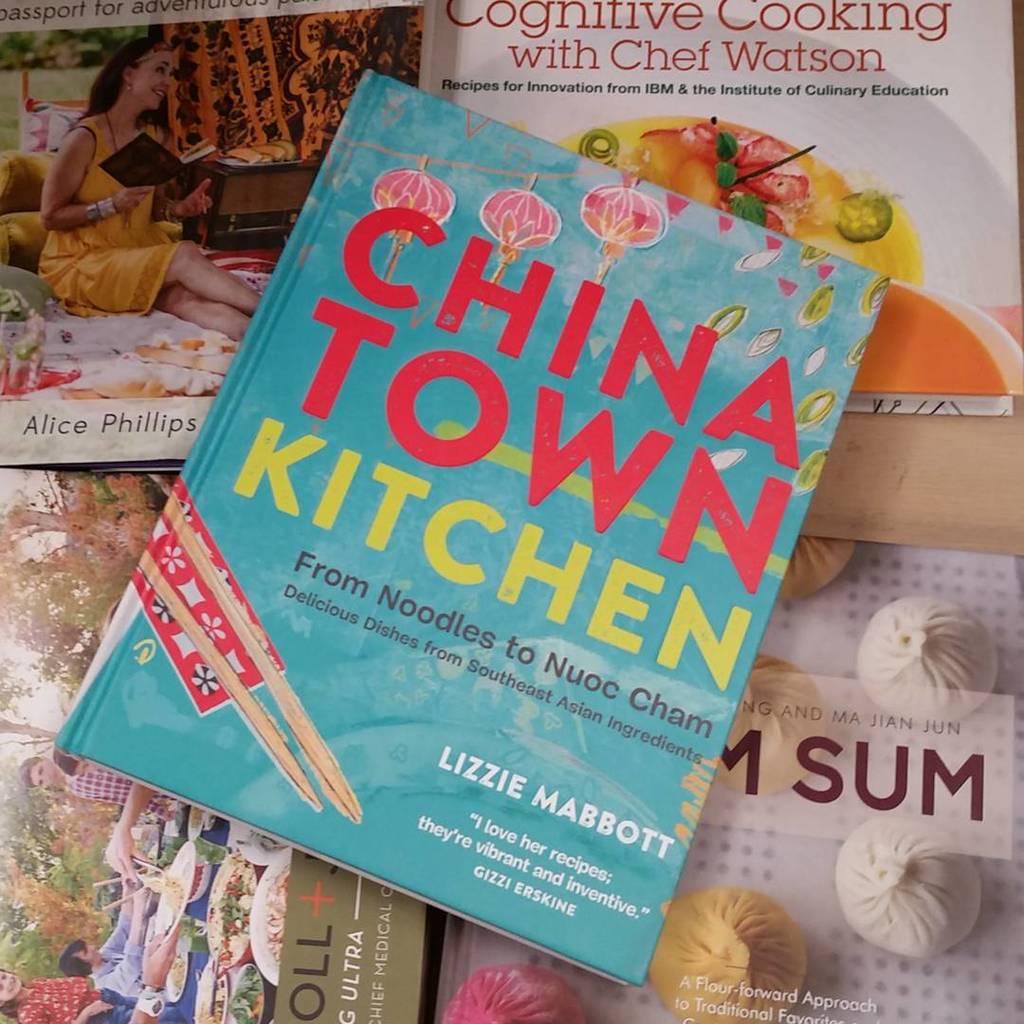Who wrote that book on the top of the pile?
Make the answer very short. Lizzie mabbott. Is this book about china town?
Ensure brevity in your answer.  Yes. 